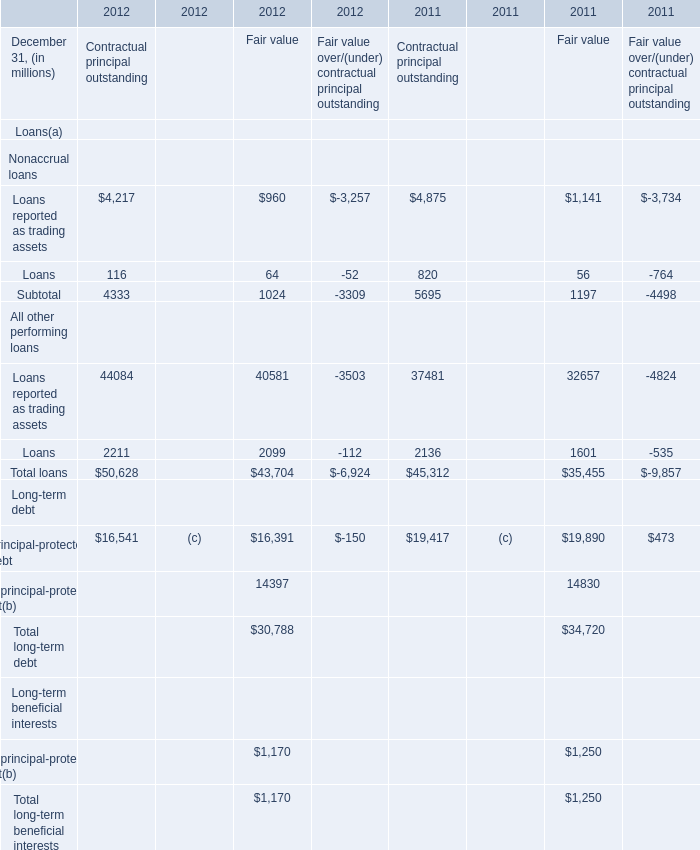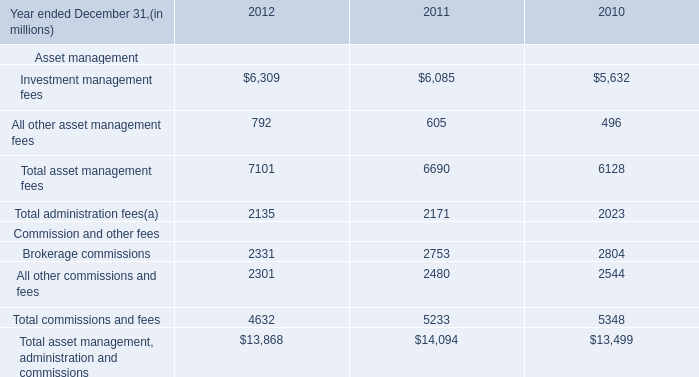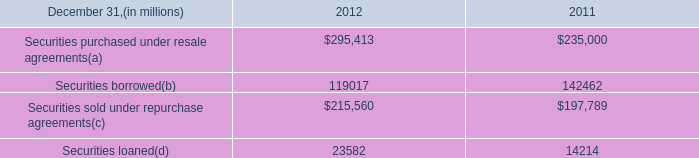in 2012 what was the percent of the securities loaned included in the accounted for at fair value 
Computations: (457 / 23582)
Answer: 0.01938. 